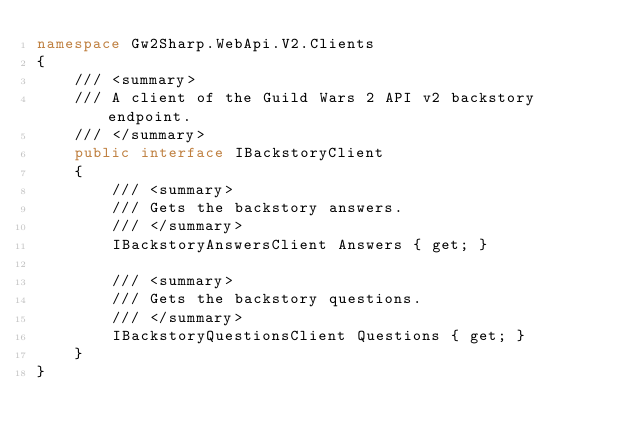Convert code to text. <code><loc_0><loc_0><loc_500><loc_500><_C#_>namespace Gw2Sharp.WebApi.V2.Clients
{
    /// <summary>
    /// A client of the Guild Wars 2 API v2 backstory endpoint.
    /// </summary>
    public interface IBackstoryClient
    {
        /// <summary>
        /// Gets the backstory answers.
        /// </summary>
        IBackstoryAnswersClient Answers { get; }

        /// <summary>
        /// Gets the backstory questions.
        /// </summary>
        IBackstoryQuestionsClient Questions { get; }
    }
}
</code> 